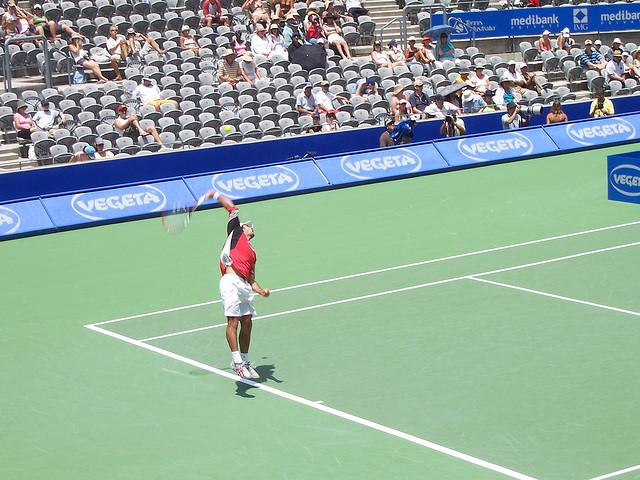What is the brand advertising along the sides of the court?

Choices:
A) condiment
B) sun glasses
C) cars
D) clothes condiment 